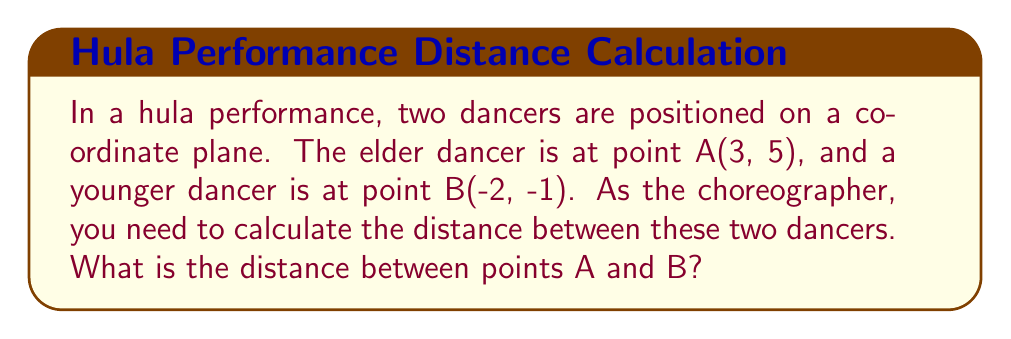Give your solution to this math problem. To find the distance between two points on a coordinate plane, we can use the distance formula, which is derived from the Pythagorean theorem:

$$d = \sqrt{(x_2 - x_1)^2 + (y_2 - y_1)^2}$$

Where $(x_1, y_1)$ are the coordinates of the first point and $(x_2, y_2)$ are the coordinates of the second point.

Let's plug in our values:
* Point A (elder dancer): $(x_1, y_1) = (3, 5)$
* Point B (younger dancer): $(x_2, y_2) = (-2, -1)$

Now, let's calculate:

1) $x_2 - x_1 = -2 - 3 = -5$
2) $y_2 - y_1 = -1 - 5 = -6$

Plugging these into our formula:

$$\begin{align}
d &= \sqrt{(-5)^2 + (-6)^2} \\
&= \sqrt{25 + 36} \\
&= \sqrt{61} \\
&\approx 7.81
\end{align}$$

Therefore, the distance between the two dancers is $\sqrt{61}$ units, or approximately 7.81 units.

[asy]
unitsize(1cm);
dot((3,5));
dot((-2,-1));
draw((3,5)--(-2,-1),blue);
label("A(3,5)", (3,5), NE);
label("B(-2,-1)", (-2,-1), SW);
draw((-3,0)--(4,0),gray);
draw((0,-2)--(0,6),gray);
for(int i=-2; i<=3; ++i) {
  draw((i,-0.1)--(i,0.1),gray);
  label(format("%d",i), (i,-0.3), S, fontsize(8));
}
for(int i=-1; i<=5; ++i) {
  draw((-0.1,i)--(0.1,i),gray);
  label(format("%d",i), (-0.3,i), W, fontsize(8));
}
[/asy]
Answer: $\sqrt{61}$ units 